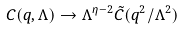Convert formula to latex. <formula><loc_0><loc_0><loc_500><loc_500>C ( q , \Lambda ) \rightarrow \Lambda ^ { \eta - 2 } \tilde { C } ( q ^ { 2 } / \Lambda ^ { 2 } )</formula> 